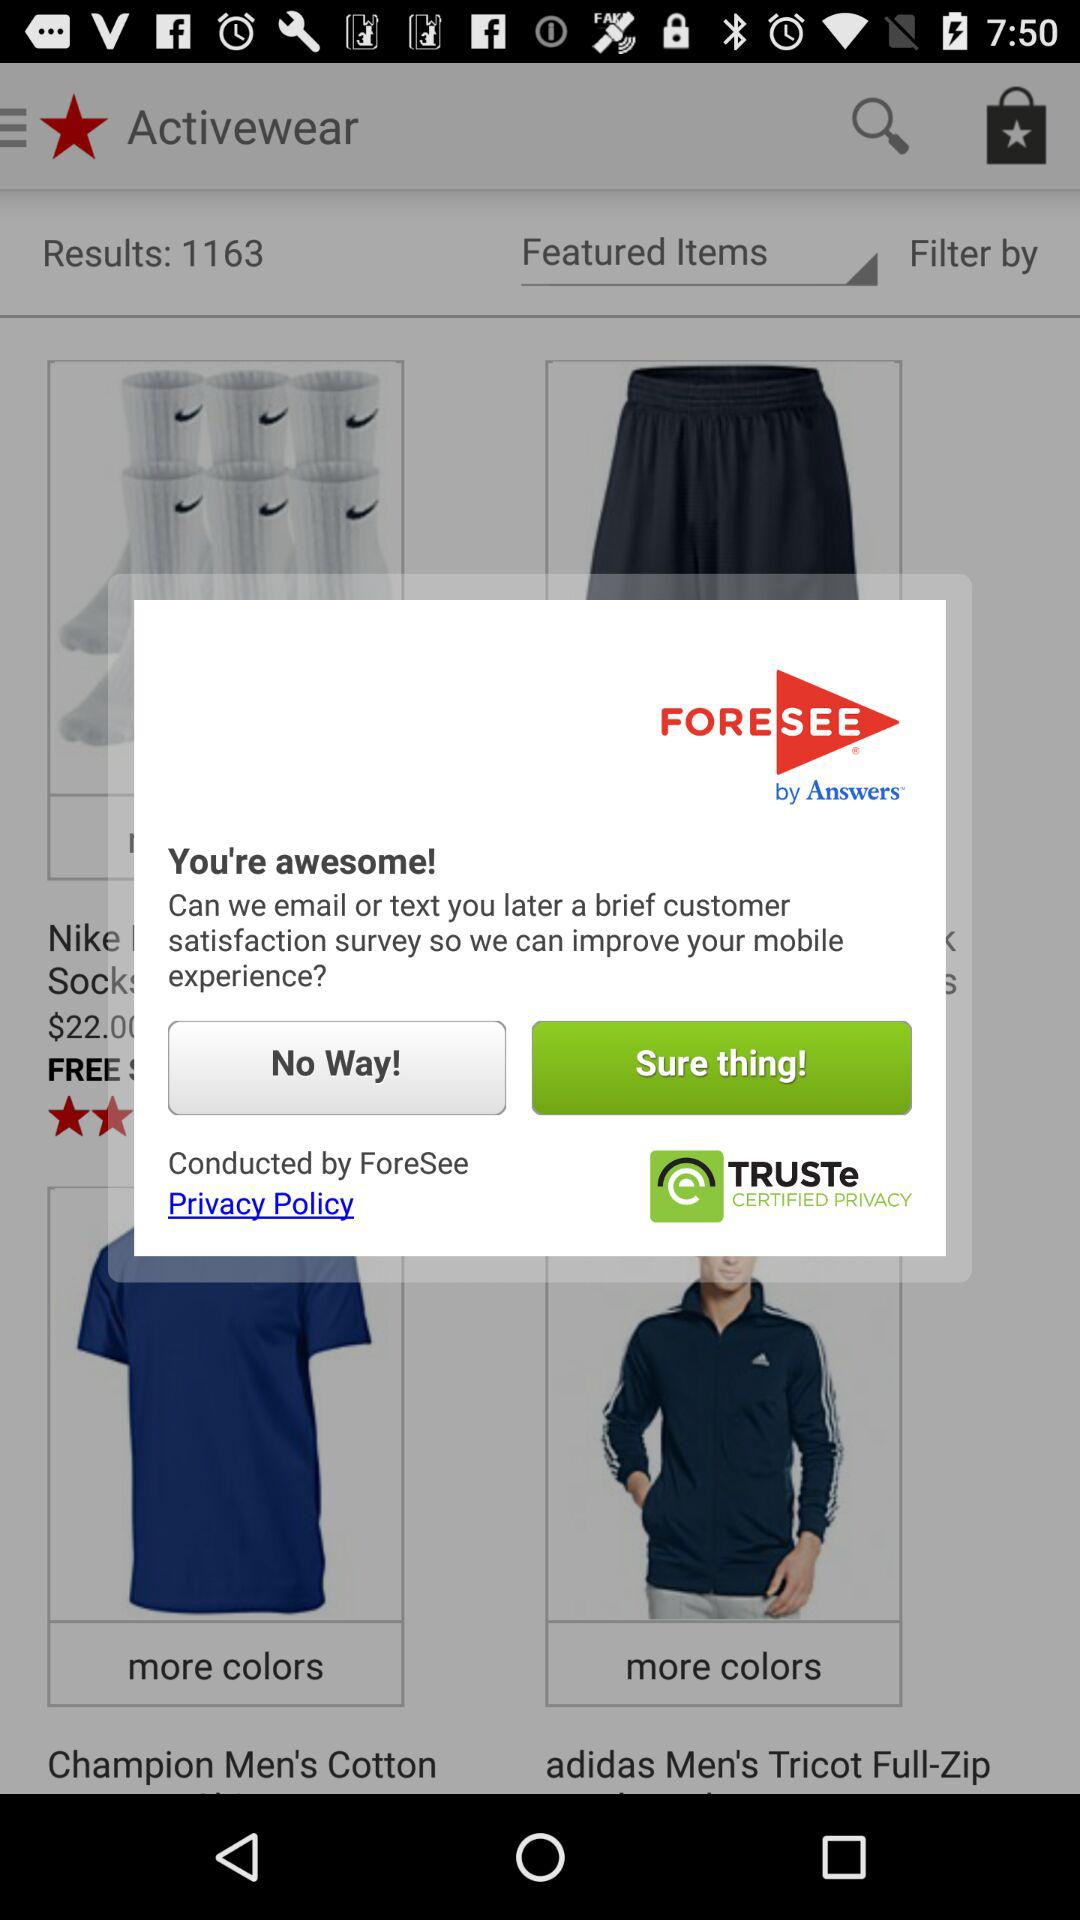What is the name of the application? The name of the application is "FORESEE". 